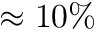Convert formula to latex. <formula><loc_0><loc_0><loc_500><loc_500>\approx 1 0 \%</formula> 